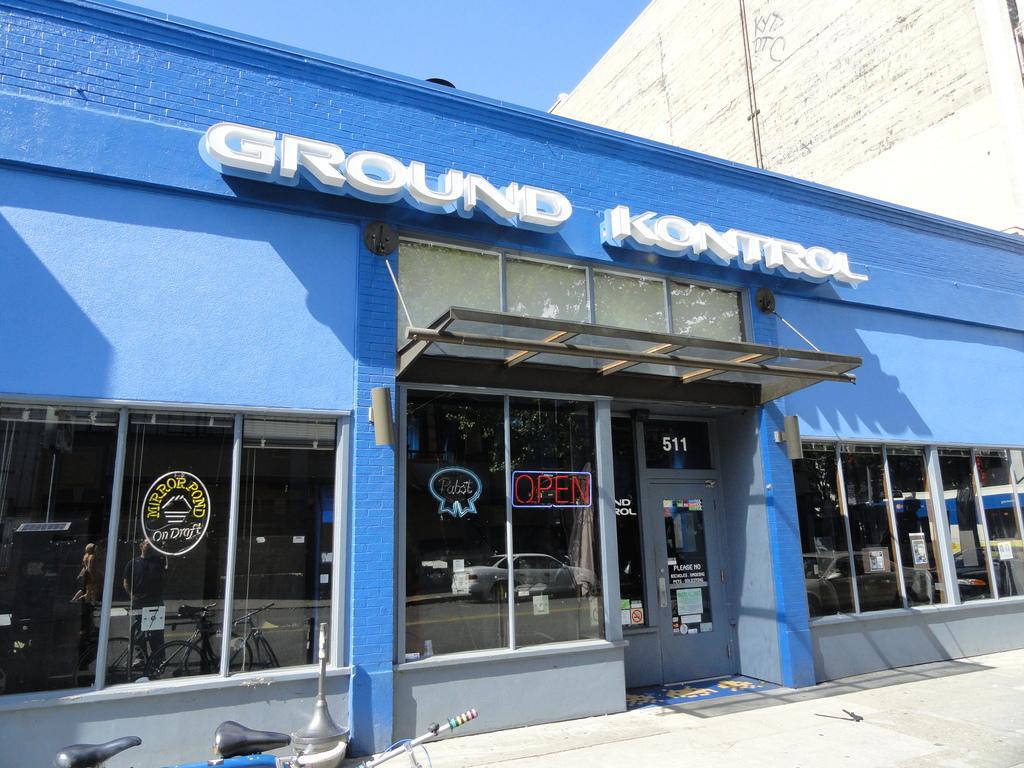Please provide a concise description of this image. In this image there is one store and in the background there is another building, and at the bottom there is a road and in the center there are some glass doors and some poles. Through the window we could see a reflection of some vehicles some persons, and some objects. 